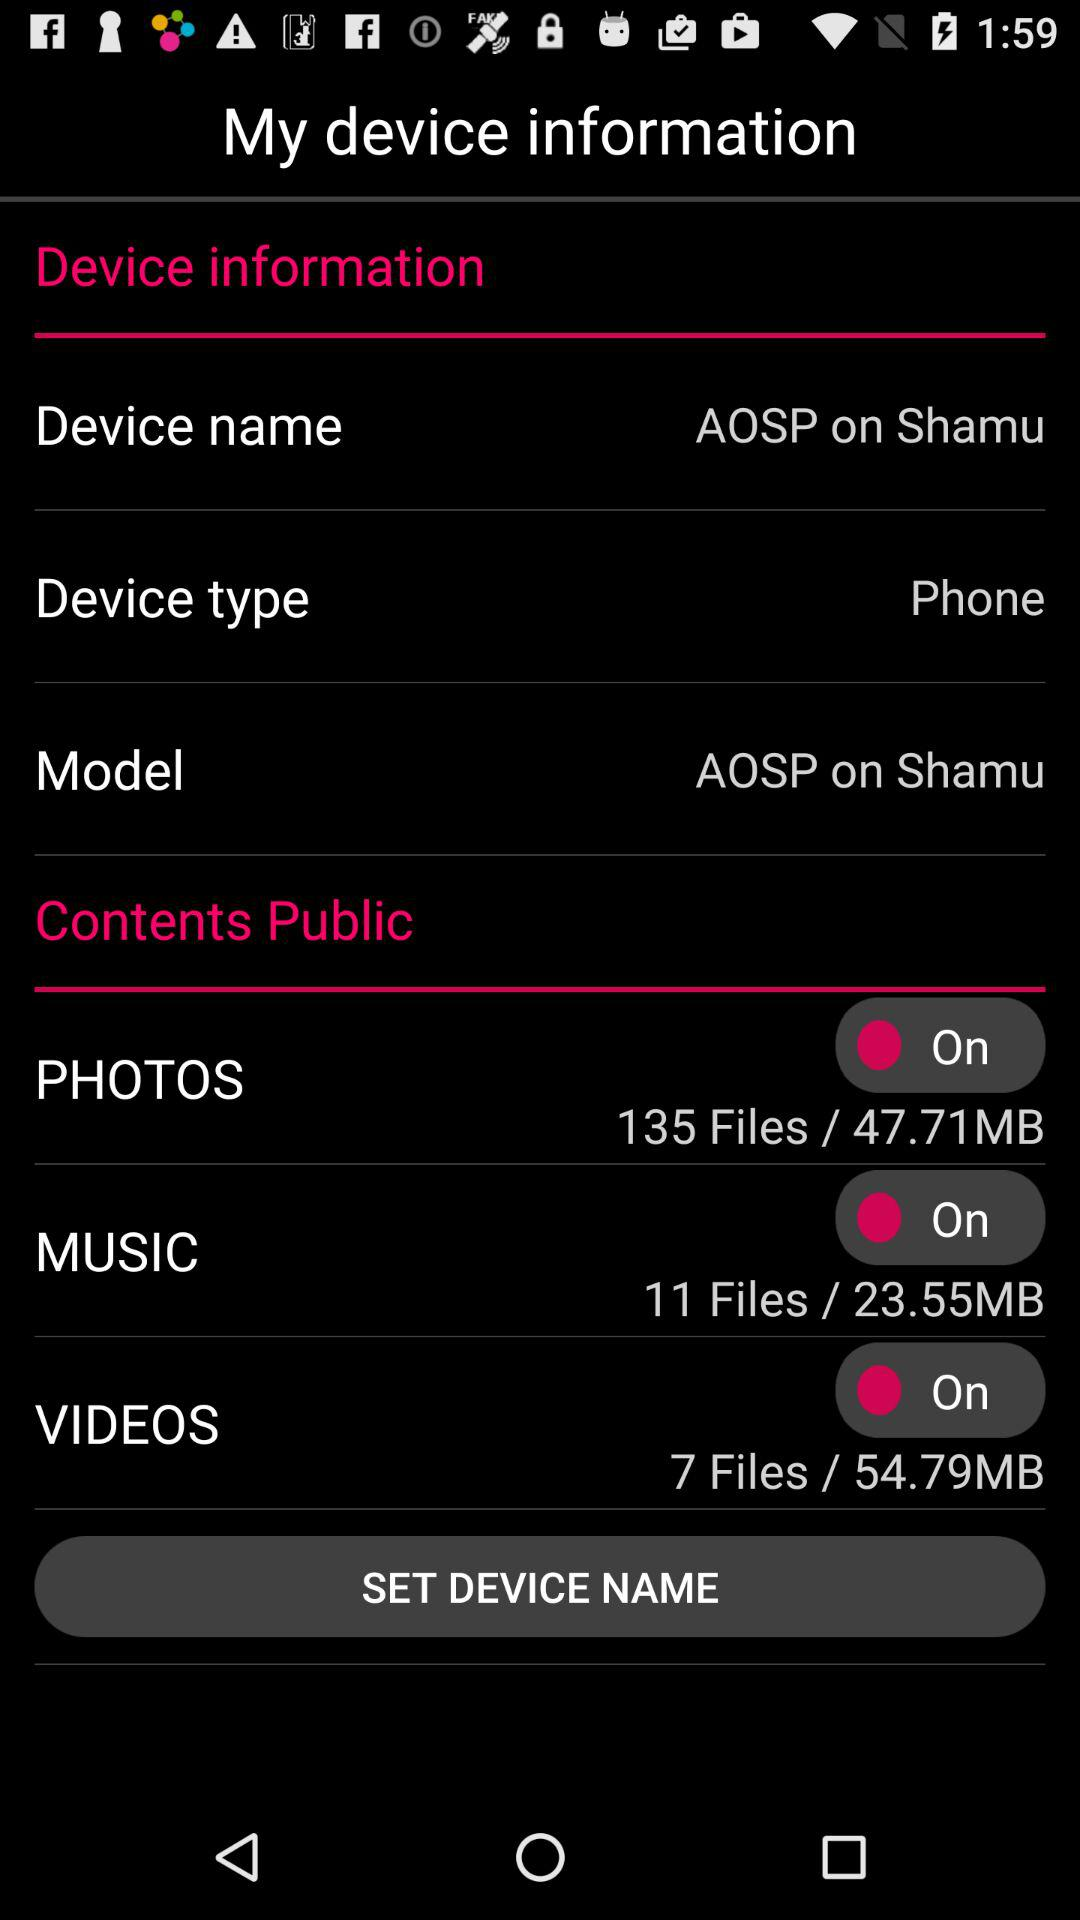In what content are the seven files available to the public? The content is "VIDEOS". 